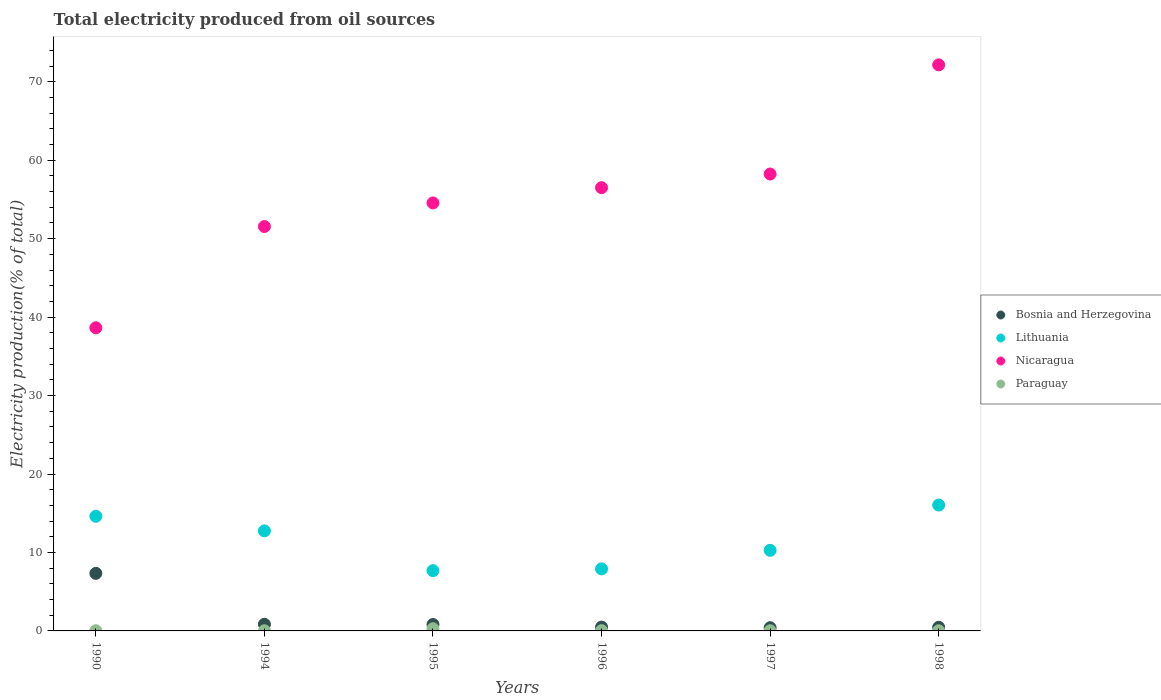How many different coloured dotlines are there?
Keep it short and to the point. 4. Is the number of dotlines equal to the number of legend labels?
Give a very brief answer. Yes. What is the total electricity produced in Lithuania in 1990?
Keep it short and to the point. 14.61. Across all years, what is the maximum total electricity produced in Lithuania?
Your response must be concise. 16.04. Across all years, what is the minimum total electricity produced in Lithuania?
Provide a short and direct response. 7.68. In which year was the total electricity produced in Lithuania maximum?
Offer a very short reply. 1998. What is the total total electricity produced in Lithuania in the graph?
Give a very brief answer. 69.27. What is the difference between the total electricity produced in Lithuania in 1990 and that in 1995?
Offer a very short reply. 6.93. What is the difference between the total electricity produced in Lithuania in 1998 and the total electricity produced in Bosnia and Herzegovina in 1995?
Provide a succinct answer. 15.23. What is the average total electricity produced in Bosnia and Herzegovina per year?
Give a very brief answer. 1.73. In the year 1990, what is the difference between the total electricity produced in Bosnia and Herzegovina and total electricity produced in Paraguay?
Provide a succinct answer. 7.31. What is the ratio of the total electricity produced in Lithuania in 1995 to that in 1997?
Your response must be concise. 0.75. Is the difference between the total electricity produced in Bosnia and Herzegovina in 1994 and 1997 greater than the difference between the total electricity produced in Paraguay in 1994 and 1997?
Provide a short and direct response. Yes. What is the difference between the highest and the second highest total electricity produced in Lithuania?
Your answer should be very brief. 1.43. What is the difference between the highest and the lowest total electricity produced in Bosnia and Herzegovina?
Your answer should be very brief. 6.93. In how many years, is the total electricity produced in Nicaragua greater than the average total electricity produced in Nicaragua taken over all years?
Keep it short and to the point. 3. Is the total electricity produced in Paraguay strictly greater than the total electricity produced in Lithuania over the years?
Offer a very short reply. No. What is the difference between two consecutive major ticks on the Y-axis?
Your response must be concise. 10. Are the values on the major ticks of Y-axis written in scientific E-notation?
Your response must be concise. No. Does the graph contain grids?
Your answer should be compact. No. Where does the legend appear in the graph?
Ensure brevity in your answer.  Center right. What is the title of the graph?
Offer a terse response. Total electricity produced from oil sources. What is the label or title of the X-axis?
Offer a very short reply. Years. What is the Electricity production(% of total) of Bosnia and Herzegovina in 1990?
Offer a terse response. 7.34. What is the Electricity production(% of total) of Lithuania in 1990?
Your response must be concise. 14.61. What is the Electricity production(% of total) in Nicaragua in 1990?
Provide a short and direct response. 38.64. What is the Electricity production(% of total) of Paraguay in 1990?
Your response must be concise. 0.03. What is the Electricity production(% of total) of Bosnia and Herzegovina in 1994?
Give a very brief answer. 0.85. What is the Electricity production(% of total) of Lithuania in 1994?
Provide a succinct answer. 12.75. What is the Electricity production(% of total) in Nicaragua in 1994?
Your answer should be compact. 51.55. What is the Electricity production(% of total) in Paraguay in 1994?
Give a very brief answer. 0.02. What is the Electricity production(% of total) in Bosnia and Herzegovina in 1995?
Make the answer very short. 0.82. What is the Electricity production(% of total) of Lithuania in 1995?
Give a very brief answer. 7.68. What is the Electricity production(% of total) of Nicaragua in 1995?
Provide a short and direct response. 54.56. What is the Electricity production(% of total) of Paraguay in 1995?
Keep it short and to the point. 0.28. What is the Electricity production(% of total) of Bosnia and Herzegovina in 1996?
Provide a succinct answer. 0.49. What is the Electricity production(% of total) in Lithuania in 1996?
Offer a very short reply. 7.91. What is the Electricity production(% of total) in Nicaragua in 1996?
Give a very brief answer. 56.5. What is the Electricity production(% of total) of Paraguay in 1996?
Provide a short and direct response. 0.03. What is the Electricity production(% of total) of Bosnia and Herzegovina in 1997?
Offer a very short reply. 0.41. What is the Electricity production(% of total) in Lithuania in 1997?
Keep it short and to the point. 10.27. What is the Electricity production(% of total) of Nicaragua in 1997?
Offer a terse response. 58.24. What is the Electricity production(% of total) in Paraguay in 1997?
Provide a short and direct response. 0.02. What is the Electricity production(% of total) of Bosnia and Herzegovina in 1998?
Your answer should be very brief. 0.46. What is the Electricity production(% of total) in Lithuania in 1998?
Your response must be concise. 16.04. What is the Electricity production(% of total) of Nicaragua in 1998?
Ensure brevity in your answer.  72.15. What is the Electricity production(% of total) of Paraguay in 1998?
Offer a terse response. 0.02. Across all years, what is the maximum Electricity production(% of total) in Bosnia and Herzegovina?
Give a very brief answer. 7.34. Across all years, what is the maximum Electricity production(% of total) of Lithuania?
Provide a succinct answer. 16.04. Across all years, what is the maximum Electricity production(% of total) in Nicaragua?
Your answer should be very brief. 72.15. Across all years, what is the maximum Electricity production(% of total) of Paraguay?
Your answer should be very brief. 0.28. Across all years, what is the minimum Electricity production(% of total) of Bosnia and Herzegovina?
Your response must be concise. 0.41. Across all years, what is the minimum Electricity production(% of total) in Lithuania?
Your answer should be very brief. 7.68. Across all years, what is the minimum Electricity production(% of total) of Nicaragua?
Your answer should be very brief. 38.64. Across all years, what is the minimum Electricity production(% of total) of Paraguay?
Make the answer very short. 0.02. What is the total Electricity production(% of total) in Bosnia and Herzegovina in the graph?
Offer a very short reply. 10.37. What is the total Electricity production(% of total) in Lithuania in the graph?
Provide a succinct answer. 69.27. What is the total Electricity production(% of total) of Nicaragua in the graph?
Your response must be concise. 331.63. What is the total Electricity production(% of total) in Paraguay in the graph?
Keep it short and to the point. 0.4. What is the difference between the Electricity production(% of total) in Bosnia and Herzegovina in 1990 and that in 1994?
Ensure brevity in your answer.  6.49. What is the difference between the Electricity production(% of total) in Lithuania in 1990 and that in 1994?
Ensure brevity in your answer.  1.86. What is the difference between the Electricity production(% of total) of Nicaragua in 1990 and that in 1994?
Offer a terse response. -12.91. What is the difference between the Electricity production(% of total) in Paraguay in 1990 and that in 1994?
Your response must be concise. 0.01. What is the difference between the Electricity production(% of total) in Bosnia and Herzegovina in 1990 and that in 1995?
Offer a terse response. 6.52. What is the difference between the Electricity production(% of total) in Lithuania in 1990 and that in 1995?
Your response must be concise. 6.93. What is the difference between the Electricity production(% of total) of Nicaragua in 1990 and that in 1995?
Make the answer very short. -15.91. What is the difference between the Electricity production(% of total) in Paraguay in 1990 and that in 1995?
Give a very brief answer. -0.26. What is the difference between the Electricity production(% of total) of Bosnia and Herzegovina in 1990 and that in 1996?
Make the answer very short. 6.85. What is the difference between the Electricity production(% of total) of Lithuania in 1990 and that in 1996?
Keep it short and to the point. 6.71. What is the difference between the Electricity production(% of total) of Nicaragua in 1990 and that in 1996?
Provide a short and direct response. -17.86. What is the difference between the Electricity production(% of total) in Paraguay in 1990 and that in 1996?
Offer a terse response. -0.01. What is the difference between the Electricity production(% of total) in Bosnia and Herzegovina in 1990 and that in 1997?
Keep it short and to the point. 6.93. What is the difference between the Electricity production(% of total) of Lithuania in 1990 and that in 1997?
Provide a succinct answer. 4.34. What is the difference between the Electricity production(% of total) of Nicaragua in 1990 and that in 1997?
Make the answer very short. -19.6. What is the difference between the Electricity production(% of total) of Paraguay in 1990 and that in 1997?
Give a very brief answer. 0. What is the difference between the Electricity production(% of total) in Bosnia and Herzegovina in 1990 and that in 1998?
Offer a terse response. 6.88. What is the difference between the Electricity production(% of total) of Lithuania in 1990 and that in 1998?
Make the answer very short. -1.43. What is the difference between the Electricity production(% of total) in Nicaragua in 1990 and that in 1998?
Your answer should be compact. -33.51. What is the difference between the Electricity production(% of total) in Paraguay in 1990 and that in 1998?
Your answer should be compact. 0. What is the difference between the Electricity production(% of total) of Bosnia and Herzegovina in 1994 and that in 1995?
Keep it short and to the point. 0.03. What is the difference between the Electricity production(% of total) in Lithuania in 1994 and that in 1995?
Offer a very short reply. 5.07. What is the difference between the Electricity production(% of total) of Nicaragua in 1994 and that in 1995?
Your answer should be very brief. -3.01. What is the difference between the Electricity production(% of total) of Paraguay in 1994 and that in 1995?
Provide a succinct answer. -0.26. What is the difference between the Electricity production(% of total) of Bosnia and Herzegovina in 1994 and that in 1996?
Keep it short and to the point. 0.36. What is the difference between the Electricity production(% of total) of Lithuania in 1994 and that in 1996?
Ensure brevity in your answer.  4.85. What is the difference between the Electricity production(% of total) of Nicaragua in 1994 and that in 1996?
Your response must be concise. -4.95. What is the difference between the Electricity production(% of total) of Paraguay in 1994 and that in 1996?
Provide a short and direct response. -0.01. What is the difference between the Electricity production(% of total) of Bosnia and Herzegovina in 1994 and that in 1997?
Offer a very short reply. 0.44. What is the difference between the Electricity production(% of total) in Lithuania in 1994 and that in 1997?
Offer a terse response. 2.48. What is the difference between the Electricity production(% of total) of Nicaragua in 1994 and that in 1997?
Offer a very short reply. -6.69. What is the difference between the Electricity production(% of total) of Paraguay in 1994 and that in 1997?
Your response must be concise. -0. What is the difference between the Electricity production(% of total) in Bosnia and Herzegovina in 1994 and that in 1998?
Ensure brevity in your answer.  0.39. What is the difference between the Electricity production(% of total) of Lithuania in 1994 and that in 1998?
Give a very brief answer. -3.29. What is the difference between the Electricity production(% of total) of Nicaragua in 1994 and that in 1998?
Your answer should be compact. -20.61. What is the difference between the Electricity production(% of total) of Paraguay in 1994 and that in 1998?
Ensure brevity in your answer.  -0. What is the difference between the Electricity production(% of total) of Bosnia and Herzegovina in 1995 and that in 1996?
Your answer should be compact. 0.33. What is the difference between the Electricity production(% of total) in Lithuania in 1995 and that in 1996?
Offer a very short reply. -0.22. What is the difference between the Electricity production(% of total) in Nicaragua in 1995 and that in 1996?
Your response must be concise. -1.94. What is the difference between the Electricity production(% of total) in Paraguay in 1995 and that in 1996?
Your answer should be compact. 0.25. What is the difference between the Electricity production(% of total) in Bosnia and Herzegovina in 1995 and that in 1997?
Offer a very short reply. 0.41. What is the difference between the Electricity production(% of total) of Lithuania in 1995 and that in 1997?
Your answer should be compact. -2.59. What is the difference between the Electricity production(% of total) of Nicaragua in 1995 and that in 1997?
Your answer should be compact. -3.68. What is the difference between the Electricity production(% of total) in Paraguay in 1995 and that in 1997?
Make the answer very short. 0.26. What is the difference between the Electricity production(% of total) in Bosnia and Herzegovina in 1995 and that in 1998?
Offer a very short reply. 0.36. What is the difference between the Electricity production(% of total) of Lithuania in 1995 and that in 1998?
Offer a very short reply. -8.36. What is the difference between the Electricity production(% of total) of Nicaragua in 1995 and that in 1998?
Make the answer very short. -17.6. What is the difference between the Electricity production(% of total) in Paraguay in 1995 and that in 1998?
Make the answer very short. 0.26. What is the difference between the Electricity production(% of total) in Bosnia and Herzegovina in 1996 and that in 1997?
Provide a succinct answer. 0.08. What is the difference between the Electricity production(% of total) in Lithuania in 1996 and that in 1997?
Make the answer very short. -2.37. What is the difference between the Electricity production(% of total) of Nicaragua in 1996 and that in 1997?
Ensure brevity in your answer.  -1.74. What is the difference between the Electricity production(% of total) of Paraguay in 1996 and that in 1997?
Provide a succinct answer. 0.01. What is the difference between the Electricity production(% of total) of Bosnia and Herzegovina in 1996 and that in 1998?
Offer a very short reply. 0.03. What is the difference between the Electricity production(% of total) of Lithuania in 1996 and that in 1998?
Ensure brevity in your answer.  -8.14. What is the difference between the Electricity production(% of total) of Nicaragua in 1996 and that in 1998?
Provide a succinct answer. -15.66. What is the difference between the Electricity production(% of total) in Paraguay in 1996 and that in 1998?
Your answer should be compact. 0.01. What is the difference between the Electricity production(% of total) in Bosnia and Herzegovina in 1997 and that in 1998?
Make the answer very short. -0.05. What is the difference between the Electricity production(% of total) of Lithuania in 1997 and that in 1998?
Provide a succinct answer. -5.77. What is the difference between the Electricity production(% of total) of Nicaragua in 1997 and that in 1998?
Your answer should be compact. -13.91. What is the difference between the Electricity production(% of total) of Paraguay in 1997 and that in 1998?
Give a very brief answer. 0. What is the difference between the Electricity production(% of total) in Bosnia and Herzegovina in 1990 and the Electricity production(% of total) in Lithuania in 1994?
Provide a short and direct response. -5.41. What is the difference between the Electricity production(% of total) in Bosnia and Herzegovina in 1990 and the Electricity production(% of total) in Nicaragua in 1994?
Keep it short and to the point. -44.21. What is the difference between the Electricity production(% of total) of Bosnia and Herzegovina in 1990 and the Electricity production(% of total) of Paraguay in 1994?
Your answer should be compact. 7.32. What is the difference between the Electricity production(% of total) of Lithuania in 1990 and the Electricity production(% of total) of Nicaragua in 1994?
Your answer should be very brief. -36.93. What is the difference between the Electricity production(% of total) of Lithuania in 1990 and the Electricity production(% of total) of Paraguay in 1994?
Your answer should be very brief. 14.59. What is the difference between the Electricity production(% of total) in Nicaragua in 1990 and the Electricity production(% of total) in Paraguay in 1994?
Provide a short and direct response. 38.62. What is the difference between the Electricity production(% of total) in Bosnia and Herzegovina in 1990 and the Electricity production(% of total) in Lithuania in 1995?
Keep it short and to the point. -0.34. What is the difference between the Electricity production(% of total) in Bosnia and Herzegovina in 1990 and the Electricity production(% of total) in Nicaragua in 1995?
Your answer should be compact. -47.22. What is the difference between the Electricity production(% of total) of Bosnia and Herzegovina in 1990 and the Electricity production(% of total) of Paraguay in 1995?
Keep it short and to the point. 7.06. What is the difference between the Electricity production(% of total) of Lithuania in 1990 and the Electricity production(% of total) of Nicaragua in 1995?
Your response must be concise. -39.94. What is the difference between the Electricity production(% of total) of Lithuania in 1990 and the Electricity production(% of total) of Paraguay in 1995?
Your answer should be very brief. 14.33. What is the difference between the Electricity production(% of total) of Nicaragua in 1990 and the Electricity production(% of total) of Paraguay in 1995?
Your response must be concise. 38.36. What is the difference between the Electricity production(% of total) of Bosnia and Herzegovina in 1990 and the Electricity production(% of total) of Lithuania in 1996?
Offer a terse response. -0.57. What is the difference between the Electricity production(% of total) in Bosnia and Herzegovina in 1990 and the Electricity production(% of total) in Nicaragua in 1996?
Give a very brief answer. -49.16. What is the difference between the Electricity production(% of total) in Bosnia and Herzegovina in 1990 and the Electricity production(% of total) in Paraguay in 1996?
Keep it short and to the point. 7.31. What is the difference between the Electricity production(% of total) of Lithuania in 1990 and the Electricity production(% of total) of Nicaragua in 1996?
Keep it short and to the point. -41.88. What is the difference between the Electricity production(% of total) of Lithuania in 1990 and the Electricity production(% of total) of Paraguay in 1996?
Your answer should be compact. 14.58. What is the difference between the Electricity production(% of total) in Nicaragua in 1990 and the Electricity production(% of total) in Paraguay in 1996?
Your answer should be very brief. 38.61. What is the difference between the Electricity production(% of total) in Bosnia and Herzegovina in 1990 and the Electricity production(% of total) in Lithuania in 1997?
Ensure brevity in your answer.  -2.93. What is the difference between the Electricity production(% of total) of Bosnia and Herzegovina in 1990 and the Electricity production(% of total) of Nicaragua in 1997?
Give a very brief answer. -50.9. What is the difference between the Electricity production(% of total) of Bosnia and Herzegovina in 1990 and the Electricity production(% of total) of Paraguay in 1997?
Make the answer very short. 7.32. What is the difference between the Electricity production(% of total) of Lithuania in 1990 and the Electricity production(% of total) of Nicaragua in 1997?
Ensure brevity in your answer.  -43.63. What is the difference between the Electricity production(% of total) in Lithuania in 1990 and the Electricity production(% of total) in Paraguay in 1997?
Offer a terse response. 14.59. What is the difference between the Electricity production(% of total) of Nicaragua in 1990 and the Electricity production(% of total) of Paraguay in 1997?
Provide a succinct answer. 38.62. What is the difference between the Electricity production(% of total) of Bosnia and Herzegovina in 1990 and the Electricity production(% of total) of Lithuania in 1998?
Your answer should be compact. -8.7. What is the difference between the Electricity production(% of total) of Bosnia and Herzegovina in 1990 and the Electricity production(% of total) of Nicaragua in 1998?
Offer a very short reply. -64.81. What is the difference between the Electricity production(% of total) of Bosnia and Herzegovina in 1990 and the Electricity production(% of total) of Paraguay in 1998?
Provide a short and direct response. 7.32. What is the difference between the Electricity production(% of total) in Lithuania in 1990 and the Electricity production(% of total) in Nicaragua in 1998?
Give a very brief answer. -57.54. What is the difference between the Electricity production(% of total) of Lithuania in 1990 and the Electricity production(% of total) of Paraguay in 1998?
Offer a terse response. 14.59. What is the difference between the Electricity production(% of total) of Nicaragua in 1990 and the Electricity production(% of total) of Paraguay in 1998?
Keep it short and to the point. 38.62. What is the difference between the Electricity production(% of total) of Bosnia and Herzegovina in 1994 and the Electricity production(% of total) of Lithuania in 1995?
Provide a short and direct response. -6.84. What is the difference between the Electricity production(% of total) of Bosnia and Herzegovina in 1994 and the Electricity production(% of total) of Nicaragua in 1995?
Give a very brief answer. -53.71. What is the difference between the Electricity production(% of total) in Bosnia and Herzegovina in 1994 and the Electricity production(% of total) in Paraguay in 1995?
Your answer should be compact. 0.57. What is the difference between the Electricity production(% of total) in Lithuania in 1994 and the Electricity production(% of total) in Nicaragua in 1995?
Give a very brief answer. -41.8. What is the difference between the Electricity production(% of total) in Lithuania in 1994 and the Electricity production(% of total) in Paraguay in 1995?
Offer a very short reply. 12.47. What is the difference between the Electricity production(% of total) in Nicaragua in 1994 and the Electricity production(% of total) in Paraguay in 1995?
Your response must be concise. 51.26. What is the difference between the Electricity production(% of total) of Bosnia and Herzegovina in 1994 and the Electricity production(% of total) of Lithuania in 1996?
Offer a terse response. -7.06. What is the difference between the Electricity production(% of total) in Bosnia and Herzegovina in 1994 and the Electricity production(% of total) in Nicaragua in 1996?
Keep it short and to the point. -55.65. What is the difference between the Electricity production(% of total) in Bosnia and Herzegovina in 1994 and the Electricity production(% of total) in Paraguay in 1996?
Offer a terse response. 0.81. What is the difference between the Electricity production(% of total) of Lithuania in 1994 and the Electricity production(% of total) of Nicaragua in 1996?
Give a very brief answer. -43.75. What is the difference between the Electricity production(% of total) of Lithuania in 1994 and the Electricity production(% of total) of Paraguay in 1996?
Offer a terse response. 12.72. What is the difference between the Electricity production(% of total) of Nicaragua in 1994 and the Electricity production(% of total) of Paraguay in 1996?
Give a very brief answer. 51.51. What is the difference between the Electricity production(% of total) in Bosnia and Herzegovina in 1994 and the Electricity production(% of total) in Lithuania in 1997?
Give a very brief answer. -9.42. What is the difference between the Electricity production(% of total) in Bosnia and Herzegovina in 1994 and the Electricity production(% of total) in Nicaragua in 1997?
Provide a short and direct response. -57.39. What is the difference between the Electricity production(% of total) of Bosnia and Herzegovina in 1994 and the Electricity production(% of total) of Paraguay in 1997?
Provide a short and direct response. 0.83. What is the difference between the Electricity production(% of total) in Lithuania in 1994 and the Electricity production(% of total) in Nicaragua in 1997?
Provide a succinct answer. -45.49. What is the difference between the Electricity production(% of total) in Lithuania in 1994 and the Electricity production(% of total) in Paraguay in 1997?
Provide a short and direct response. 12.73. What is the difference between the Electricity production(% of total) in Nicaragua in 1994 and the Electricity production(% of total) in Paraguay in 1997?
Provide a succinct answer. 51.52. What is the difference between the Electricity production(% of total) in Bosnia and Herzegovina in 1994 and the Electricity production(% of total) in Lithuania in 1998?
Offer a very short reply. -15.2. What is the difference between the Electricity production(% of total) in Bosnia and Herzegovina in 1994 and the Electricity production(% of total) in Nicaragua in 1998?
Offer a terse response. -71.31. What is the difference between the Electricity production(% of total) in Bosnia and Herzegovina in 1994 and the Electricity production(% of total) in Paraguay in 1998?
Give a very brief answer. 0.83. What is the difference between the Electricity production(% of total) in Lithuania in 1994 and the Electricity production(% of total) in Nicaragua in 1998?
Ensure brevity in your answer.  -59.4. What is the difference between the Electricity production(% of total) of Lithuania in 1994 and the Electricity production(% of total) of Paraguay in 1998?
Your answer should be compact. 12.73. What is the difference between the Electricity production(% of total) in Nicaragua in 1994 and the Electricity production(% of total) in Paraguay in 1998?
Keep it short and to the point. 51.52. What is the difference between the Electricity production(% of total) of Bosnia and Herzegovina in 1995 and the Electricity production(% of total) of Lithuania in 1996?
Give a very brief answer. -7.09. What is the difference between the Electricity production(% of total) in Bosnia and Herzegovina in 1995 and the Electricity production(% of total) in Nicaragua in 1996?
Your response must be concise. -55.68. What is the difference between the Electricity production(% of total) of Bosnia and Herzegovina in 1995 and the Electricity production(% of total) of Paraguay in 1996?
Your answer should be very brief. 0.78. What is the difference between the Electricity production(% of total) in Lithuania in 1995 and the Electricity production(% of total) in Nicaragua in 1996?
Make the answer very short. -48.81. What is the difference between the Electricity production(% of total) of Lithuania in 1995 and the Electricity production(% of total) of Paraguay in 1996?
Offer a terse response. 7.65. What is the difference between the Electricity production(% of total) in Nicaragua in 1995 and the Electricity production(% of total) in Paraguay in 1996?
Provide a succinct answer. 54.52. What is the difference between the Electricity production(% of total) in Bosnia and Herzegovina in 1995 and the Electricity production(% of total) in Lithuania in 1997?
Offer a terse response. -9.45. What is the difference between the Electricity production(% of total) in Bosnia and Herzegovina in 1995 and the Electricity production(% of total) in Nicaragua in 1997?
Offer a very short reply. -57.42. What is the difference between the Electricity production(% of total) of Bosnia and Herzegovina in 1995 and the Electricity production(% of total) of Paraguay in 1997?
Ensure brevity in your answer.  0.8. What is the difference between the Electricity production(% of total) in Lithuania in 1995 and the Electricity production(% of total) in Nicaragua in 1997?
Make the answer very short. -50.55. What is the difference between the Electricity production(% of total) in Lithuania in 1995 and the Electricity production(% of total) in Paraguay in 1997?
Provide a short and direct response. 7.66. What is the difference between the Electricity production(% of total) of Nicaragua in 1995 and the Electricity production(% of total) of Paraguay in 1997?
Provide a succinct answer. 54.53. What is the difference between the Electricity production(% of total) in Bosnia and Herzegovina in 1995 and the Electricity production(% of total) in Lithuania in 1998?
Keep it short and to the point. -15.23. What is the difference between the Electricity production(% of total) of Bosnia and Herzegovina in 1995 and the Electricity production(% of total) of Nicaragua in 1998?
Your response must be concise. -71.34. What is the difference between the Electricity production(% of total) in Bosnia and Herzegovina in 1995 and the Electricity production(% of total) in Paraguay in 1998?
Your answer should be very brief. 0.8. What is the difference between the Electricity production(% of total) in Lithuania in 1995 and the Electricity production(% of total) in Nicaragua in 1998?
Provide a short and direct response. -64.47. What is the difference between the Electricity production(% of total) of Lithuania in 1995 and the Electricity production(% of total) of Paraguay in 1998?
Ensure brevity in your answer.  7.66. What is the difference between the Electricity production(% of total) in Nicaragua in 1995 and the Electricity production(% of total) in Paraguay in 1998?
Your answer should be compact. 54.53. What is the difference between the Electricity production(% of total) in Bosnia and Herzegovina in 1996 and the Electricity production(% of total) in Lithuania in 1997?
Your answer should be very brief. -9.78. What is the difference between the Electricity production(% of total) in Bosnia and Herzegovina in 1996 and the Electricity production(% of total) in Nicaragua in 1997?
Ensure brevity in your answer.  -57.75. What is the difference between the Electricity production(% of total) of Bosnia and Herzegovina in 1996 and the Electricity production(% of total) of Paraguay in 1997?
Ensure brevity in your answer.  0.47. What is the difference between the Electricity production(% of total) in Lithuania in 1996 and the Electricity production(% of total) in Nicaragua in 1997?
Your answer should be very brief. -50.33. What is the difference between the Electricity production(% of total) of Lithuania in 1996 and the Electricity production(% of total) of Paraguay in 1997?
Your answer should be compact. 7.88. What is the difference between the Electricity production(% of total) of Nicaragua in 1996 and the Electricity production(% of total) of Paraguay in 1997?
Your response must be concise. 56.48. What is the difference between the Electricity production(% of total) of Bosnia and Herzegovina in 1996 and the Electricity production(% of total) of Lithuania in 1998?
Offer a very short reply. -15.55. What is the difference between the Electricity production(% of total) of Bosnia and Herzegovina in 1996 and the Electricity production(% of total) of Nicaragua in 1998?
Give a very brief answer. -71.66. What is the difference between the Electricity production(% of total) of Bosnia and Herzegovina in 1996 and the Electricity production(% of total) of Paraguay in 1998?
Keep it short and to the point. 0.47. What is the difference between the Electricity production(% of total) in Lithuania in 1996 and the Electricity production(% of total) in Nicaragua in 1998?
Offer a terse response. -64.25. What is the difference between the Electricity production(% of total) of Lithuania in 1996 and the Electricity production(% of total) of Paraguay in 1998?
Your response must be concise. 7.88. What is the difference between the Electricity production(% of total) of Nicaragua in 1996 and the Electricity production(% of total) of Paraguay in 1998?
Your response must be concise. 56.48. What is the difference between the Electricity production(% of total) in Bosnia and Herzegovina in 1997 and the Electricity production(% of total) in Lithuania in 1998?
Keep it short and to the point. -15.63. What is the difference between the Electricity production(% of total) in Bosnia and Herzegovina in 1997 and the Electricity production(% of total) in Nicaragua in 1998?
Offer a very short reply. -71.74. What is the difference between the Electricity production(% of total) in Bosnia and Herzegovina in 1997 and the Electricity production(% of total) in Paraguay in 1998?
Your answer should be very brief. 0.39. What is the difference between the Electricity production(% of total) in Lithuania in 1997 and the Electricity production(% of total) in Nicaragua in 1998?
Offer a very short reply. -61.88. What is the difference between the Electricity production(% of total) in Lithuania in 1997 and the Electricity production(% of total) in Paraguay in 1998?
Provide a succinct answer. 10.25. What is the difference between the Electricity production(% of total) in Nicaragua in 1997 and the Electricity production(% of total) in Paraguay in 1998?
Give a very brief answer. 58.22. What is the average Electricity production(% of total) of Bosnia and Herzegovina per year?
Your answer should be compact. 1.73. What is the average Electricity production(% of total) in Lithuania per year?
Provide a succinct answer. 11.55. What is the average Electricity production(% of total) in Nicaragua per year?
Provide a short and direct response. 55.27. What is the average Electricity production(% of total) in Paraguay per year?
Offer a very short reply. 0.07. In the year 1990, what is the difference between the Electricity production(% of total) of Bosnia and Herzegovina and Electricity production(% of total) of Lithuania?
Keep it short and to the point. -7.27. In the year 1990, what is the difference between the Electricity production(% of total) in Bosnia and Herzegovina and Electricity production(% of total) in Nicaragua?
Make the answer very short. -31.3. In the year 1990, what is the difference between the Electricity production(% of total) of Bosnia and Herzegovina and Electricity production(% of total) of Paraguay?
Provide a short and direct response. 7.31. In the year 1990, what is the difference between the Electricity production(% of total) of Lithuania and Electricity production(% of total) of Nicaragua?
Give a very brief answer. -24.03. In the year 1990, what is the difference between the Electricity production(% of total) in Lithuania and Electricity production(% of total) in Paraguay?
Provide a short and direct response. 14.59. In the year 1990, what is the difference between the Electricity production(% of total) of Nicaragua and Electricity production(% of total) of Paraguay?
Your response must be concise. 38.62. In the year 1994, what is the difference between the Electricity production(% of total) of Bosnia and Herzegovina and Electricity production(% of total) of Lithuania?
Offer a terse response. -11.9. In the year 1994, what is the difference between the Electricity production(% of total) in Bosnia and Herzegovina and Electricity production(% of total) in Nicaragua?
Provide a short and direct response. -50.7. In the year 1994, what is the difference between the Electricity production(% of total) of Bosnia and Herzegovina and Electricity production(% of total) of Paraguay?
Provide a short and direct response. 0.83. In the year 1994, what is the difference between the Electricity production(% of total) of Lithuania and Electricity production(% of total) of Nicaragua?
Make the answer very short. -38.79. In the year 1994, what is the difference between the Electricity production(% of total) in Lithuania and Electricity production(% of total) in Paraguay?
Ensure brevity in your answer.  12.73. In the year 1994, what is the difference between the Electricity production(% of total) of Nicaragua and Electricity production(% of total) of Paraguay?
Offer a very short reply. 51.53. In the year 1995, what is the difference between the Electricity production(% of total) of Bosnia and Herzegovina and Electricity production(% of total) of Lithuania?
Provide a succinct answer. -6.87. In the year 1995, what is the difference between the Electricity production(% of total) of Bosnia and Herzegovina and Electricity production(% of total) of Nicaragua?
Your response must be concise. -53.74. In the year 1995, what is the difference between the Electricity production(% of total) of Bosnia and Herzegovina and Electricity production(% of total) of Paraguay?
Your answer should be compact. 0.54. In the year 1995, what is the difference between the Electricity production(% of total) in Lithuania and Electricity production(% of total) in Nicaragua?
Provide a succinct answer. -46.87. In the year 1995, what is the difference between the Electricity production(% of total) of Lithuania and Electricity production(% of total) of Paraguay?
Offer a terse response. 7.4. In the year 1995, what is the difference between the Electricity production(% of total) of Nicaragua and Electricity production(% of total) of Paraguay?
Your answer should be very brief. 54.27. In the year 1996, what is the difference between the Electricity production(% of total) of Bosnia and Herzegovina and Electricity production(% of total) of Lithuania?
Provide a succinct answer. -7.42. In the year 1996, what is the difference between the Electricity production(% of total) in Bosnia and Herzegovina and Electricity production(% of total) in Nicaragua?
Provide a succinct answer. -56.01. In the year 1996, what is the difference between the Electricity production(% of total) in Bosnia and Herzegovina and Electricity production(% of total) in Paraguay?
Your answer should be very brief. 0.46. In the year 1996, what is the difference between the Electricity production(% of total) of Lithuania and Electricity production(% of total) of Nicaragua?
Make the answer very short. -48.59. In the year 1996, what is the difference between the Electricity production(% of total) of Lithuania and Electricity production(% of total) of Paraguay?
Provide a succinct answer. 7.87. In the year 1996, what is the difference between the Electricity production(% of total) of Nicaragua and Electricity production(% of total) of Paraguay?
Keep it short and to the point. 56.46. In the year 1997, what is the difference between the Electricity production(% of total) in Bosnia and Herzegovina and Electricity production(% of total) in Lithuania?
Give a very brief answer. -9.86. In the year 1997, what is the difference between the Electricity production(% of total) of Bosnia and Herzegovina and Electricity production(% of total) of Nicaragua?
Give a very brief answer. -57.83. In the year 1997, what is the difference between the Electricity production(% of total) of Bosnia and Herzegovina and Electricity production(% of total) of Paraguay?
Your answer should be compact. 0.39. In the year 1997, what is the difference between the Electricity production(% of total) in Lithuania and Electricity production(% of total) in Nicaragua?
Offer a terse response. -47.97. In the year 1997, what is the difference between the Electricity production(% of total) in Lithuania and Electricity production(% of total) in Paraguay?
Your answer should be compact. 10.25. In the year 1997, what is the difference between the Electricity production(% of total) of Nicaragua and Electricity production(% of total) of Paraguay?
Provide a short and direct response. 58.22. In the year 1998, what is the difference between the Electricity production(% of total) of Bosnia and Herzegovina and Electricity production(% of total) of Lithuania?
Make the answer very short. -15.58. In the year 1998, what is the difference between the Electricity production(% of total) of Bosnia and Herzegovina and Electricity production(% of total) of Nicaragua?
Ensure brevity in your answer.  -71.69. In the year 1998, what is the difference between the Electricity production(% of total) of Bosnia and Herzegovina and Electricity production(% of total) of Paraguay?
Offer a very short reply. 0.44. In the year 1998, what is the difference between the Electricity production(% of total) in Lithuania and Electricity production(% of total) in Nicaragua?
Ensure brevity in your answer.  -56.11. In the year 1998, what is the difference between the Electricity production(% of total) of Lithuania and Electricity production(% of total) of Paraguay?
Keep it short and to the point. 16.02. In the year 1998, what is the difference between the Electricity production(% of total) in Nicaragua and Electricity production(% of total) in Paraguay?
Your answer should be very brief. 72.13. What is the ratio of the Electricity production(% of total) in Bosnia and Herzegovina in 1990 to that in 1994?
Give a very brief answer. 8.65. What is the ratio of the Electricity production(% of total) in Lithuania in 1990 to that in 1994?
Ensure brevity in your answer.  1.15. What is the ratio of the Electricity production(% of total) in Nicaragua in 1990 to that in 1994?
Keep it short and to the point. 0.75. What is the ratio of the Electricity production(% of total) of Paraguay in 1990 to that in 1994?
Give a very brief answer. 1.34. What is the ratio of the Electricity production(% of total) in Bosnia and Herzegovina in 1990 to that in 1995?
Offer a very short reply. 8.97. What is the ratio of the Electricity production(% of total) of Lithuania in 1990 to that in 1995?
Your response must be concise. 1.9. What is the ratio of the Electricity production(% of total) of Nicaragua in 1990 to that in 1995?
Keep it short and to the point. 0.71. What is the ratio of the Electricity production(% of total) in Paraguay in 1990 to that in 1995?
Offer a terse response. 0.09. What is the ratio of the Electricity production(% of total) in Bosnia and Herzegovina in 1990 to that in 1996?
Provide a short and direct response. 14.97. What is the ratio of the Electricity production(% of total) of Lithuania in 1990 to that in 1996?
Ensure brevity in your answer.  1.85. What is the ratio of the Electricity production(% of total) of Nicaragua in 1990 to that in 1996?
Your answer should be compact. 0.68. What is the ratio of the Electricity production(% of total) of Paraguay in 1990 to that in 1996?
Provide a short and direct response. 0.77. What is the ratio of the Electricity production(% of total) in Bosnia and Herzegovina in 1990 to that in 1997?
Offer a very short reply. 17.87. What is the ratio of the Electricity production(% of total) in Lithuania in 1990 to that in 1997?
Provide a short and direct response. 1.42. What is the ratio of the Electricity production(% of total) in Nicaragua in 1990 to that in 1997?
Your answer should be very brief. 0.66. What is the ratio of the Electricity production(% of total) of Paraguay in 1990 to that in 1997?
Ensure brevity in your answer.  1.19. What is the ratio of the Electricity production(% of total) of Bosnia and Herzegovina in 1990 to that in 1998?
Offer a very short reply. 15.86. What is the ratio of the Electricity production(% of total) in Lithuania in 1990 to that in 1998?
Provide a succinct answer. 0.91. What is the ratio of the Electricity production(% of total) in Nicaragua in 1990 to that in 1998?
Make the answer very short. 0.54. What is the ratio of the Electricity production(% of total) in Paraguay in 1990 to that in 1998?
Ensure brevity in your answer.  1.19. What is the ratio of the Electricity production(% of total) in Bosnia and Herzegovina in 1994 to that in 1995?
Provide a succinct answer. 1.04. What is the ratio of the Electricity production(% of total) in Lithuania in 1994 to that in 1995?
Your answer should be very brief. 1.66. What is the ratio of the Electricity production(% of total) of Nicaragua in 1994 to that in 1995?
Make the answer very short. 0.94. What is the ratio of the Electricity production(% of total) of Paraguay in 1994 to that in 1995?
Make the answer very short. 0.07. What is the ratio of the Electricity production(% of total) in Bosnia and Herzegovina in 1994 to that in 1996?
Provide a succinct answer. 1.73. What is the ratio of the Electricity production(% of total) of Lithuania in 1994 to that in 1996?
Provide a short and direct response. 1.61. What is the ratio of the Electricity production(% of total) in Nicaragua in 1994 to that in 1996?
Your answer should be compact. 0.91. What is the ratio of the Electricity production(% of total) of Paraguay in 1994 to that in 1996?
Provide a short and direct response. 0.57. What is the ratio of the Electricity production(% of total) of Bosnia and Herzegovina in 1994 to that in 1997?
Offer a terse response. 2.07. What is the ratio of the Electricity production(% of total) in Lithuania in 1994 to that in 1997?
Your response must be concise. 1.24. What is the ratio of the Electricity production(% of total) in Nicaragua in 1994 to that in 1997?
Provide a succinct answer. 0.89. What is the ratio of the Electricity production(% of total) in Paraguay in 1994 to that in 1997?
Provide a succinct answer. 0.89. What is the ratio of the Electricity production(% of total) in Bosnia and Herzegovina in 1994 to that in 1998?
Offer a very short reply. 1.83. What is the ratio of the Electricity production(% of total) in Lithuania in 1994 to that in 1998?
Make the answer very short. 0.79. What is the ratio of the Electricity production(% of total) in Nicaragua in 1994 to that in 1998?
Your answer should be very brief. 0.71. What is the ratio of the Electricity production(% of total) in Paraguay in 1994 to that in 1998?
Offer a terse response. 0.89. What is the ratio of the Electricity production(% of total) in Bosnia and Herzegovina in 1995 to that in 1996?
Offer a very short reply. 1.67. What is the ratio of the Electricity production(% of total) in Lithuania in 1995 to that in 1996?
Offer a very short reply. 0.97. What is the ratio of the Electricity production(% of total) in Nicaragua in 1995 to that in 1996?
Your answer should be compact. 0.97. What is the ratio of the Electricity production(% of total) of Paraguay in 1995 to that in 1996?
Your answer should be compact. 8.42. What is the ratio of the Electricity production(% of total) in Bosnia and Herzegovina in 1995 to that in 1997?
Your answer should be compact. 1.99. What is the ratio of the Electricity production(% of total) in Lithuania in 1995 to that in 1997?
Give a very brief answer. 0.75. What is the ratio of the Electricity production(% of total) of Nicaragua in 1995 to that in 1997?
Make the answer very short. 0.94. What is the ratio of the Electricity production(% of total) in Paraguay in 1995 to that in 1997?
Your response must be concise. 13.03. What is the ratio of the Electricity production(% of total) in Bosnia and Herzegovina in 1995 to that in 1998?
Provide a short and direct response. 1.77. What is the ratio of the Electricity production(% of total) of Lithuania in 1995 to that in 1998?
Provide a short and direct response. 0.48. What is the ratio of the Electricity production(% of total) in Nicaragua in 1995 to that in 1998?
Provide a succinct answer. 0.76. What is the ratio of the Electricity production(% of total) of Paraguay in 1995 to that in 1998?
Ensure brevity in your answer.  13.03. What is the ratio of the Electricity production(% of total) in Bosnia and Herzegovina in 1996 to that in 1997?
Ensure brevity in your answer.  1.19. What is the ratio of the Electricity production(% of total) of Lithuania in 1996 to that in 1997?
Make the answer very short. 0.77. What is the ratio of the Electricity production(% of total) in Nicaragua in 1996 to that in 1997?
Your answer should be very brief. 0.97. What is the ratio of the Electricity production(% of total) of Paraguay in 1996 to that in 1997?
Provide a short and direct response. 1.55. What is the ratio of the Electricity production(% of total) of Bosnia and Herzegovina in 1996 to that in 1998?
Ensure brevity in your answer.  1.06. What is the ratio of the Electricity production(% of total) of Lithuania in 1996 to that in 1998?
Keep it short and to the point. 0.49. What is the ratio of the Electricity production(% of total) of Nicaragua in 1996 to that in 1998?
Provide a short and direct response. 0.78. What is the ratio of the Electricity production(% of total) in Paraguay in 1996 to that in 1998?
Ensure brevity in your answer.  1.55. What is the ratio of the Electricity production(% of total) of Bosnia and Herzegovina in 1997 to that in 1998?
Your answer should be very brief. 0.89. What is the ratio of the Electricity production(% of total) of Lithuania in 1997 to that in 1998?
Give a very brief answer. 0.64. What is the ratio of the Electricity production(% of total) of Nicaragua in 1997 to that in 1998?
Give a very brief answer. 0.81. What is the ratio of the Electricity production(% of total) of Paraguay in 1997 to that in 1998?
Your answer should be compact. 1. What is the difference between the highest and the second highest Electricity production(% of total) in Bosnia and Herzegovina?
Ensure brevity in your answer.  6.49. What is the difference between the highest and the second highest Electricity production(% of total) in Lithuania?
Provide a succinct answer. 1.43. What is the difference between the highest and the second highest Electricity production(% of total) of Nicaragua?
Make the answer very short. 13.91. What is the difference between the highest and the second highest Electricity production(% of total) of Paraguay?
Your response must be concise. 0.25. What is the difference between the highest and the lowest Electricity production(% of total) of Bosnia and Herzegovina?
Offer a terse response. 6.93. What is the difference between the highest and the lowest Electricity production(% of total) of Lithuania?
Make the answer very short. 8.36. What is the difference between the highest and the lowest Electricity production(% of total) of Nicaragua?
Offer a very short reply. 33.51. What is the difference between the highest and the lowest Electricity production(% of total) of Paraguay?
Offer a very short reply. 0.26. 